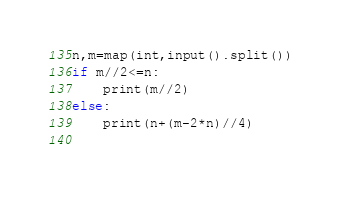Convert code to text. <code><loc_0><loc_0><loc_500><loc_500><_Python_>n,m=map(int,input().split())
if m//2<=n:
    print(m//2)
else:
    print(n+(m-2*n)//4)
    </code> 